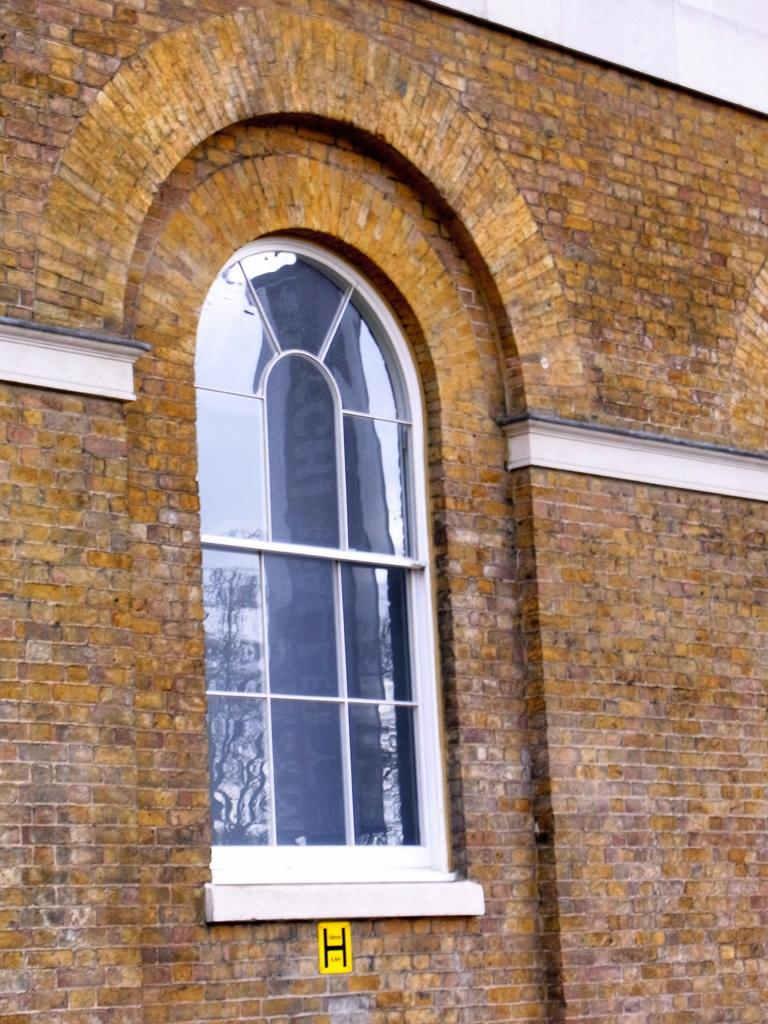Where was the image likely taken? The image was likely clicked outside, based on the presence of a wall and a window of a building in the foreground. What can be seen in the foreground of the image? In the foreground of the image, there is a wall and a window of a building. What architectural feature is visible in the image? There is an arch visible in the image. Can you describe any other items in the image? There are other unspecified items in the image, but their details are not provided. What type of collar can be seen on the vase in the image? There is no vase or collar present in the image. How does the brake system work in the image? There is no reference to a brake system in the image, as it features an outdoor scene with a wall, a window, and an arch. 